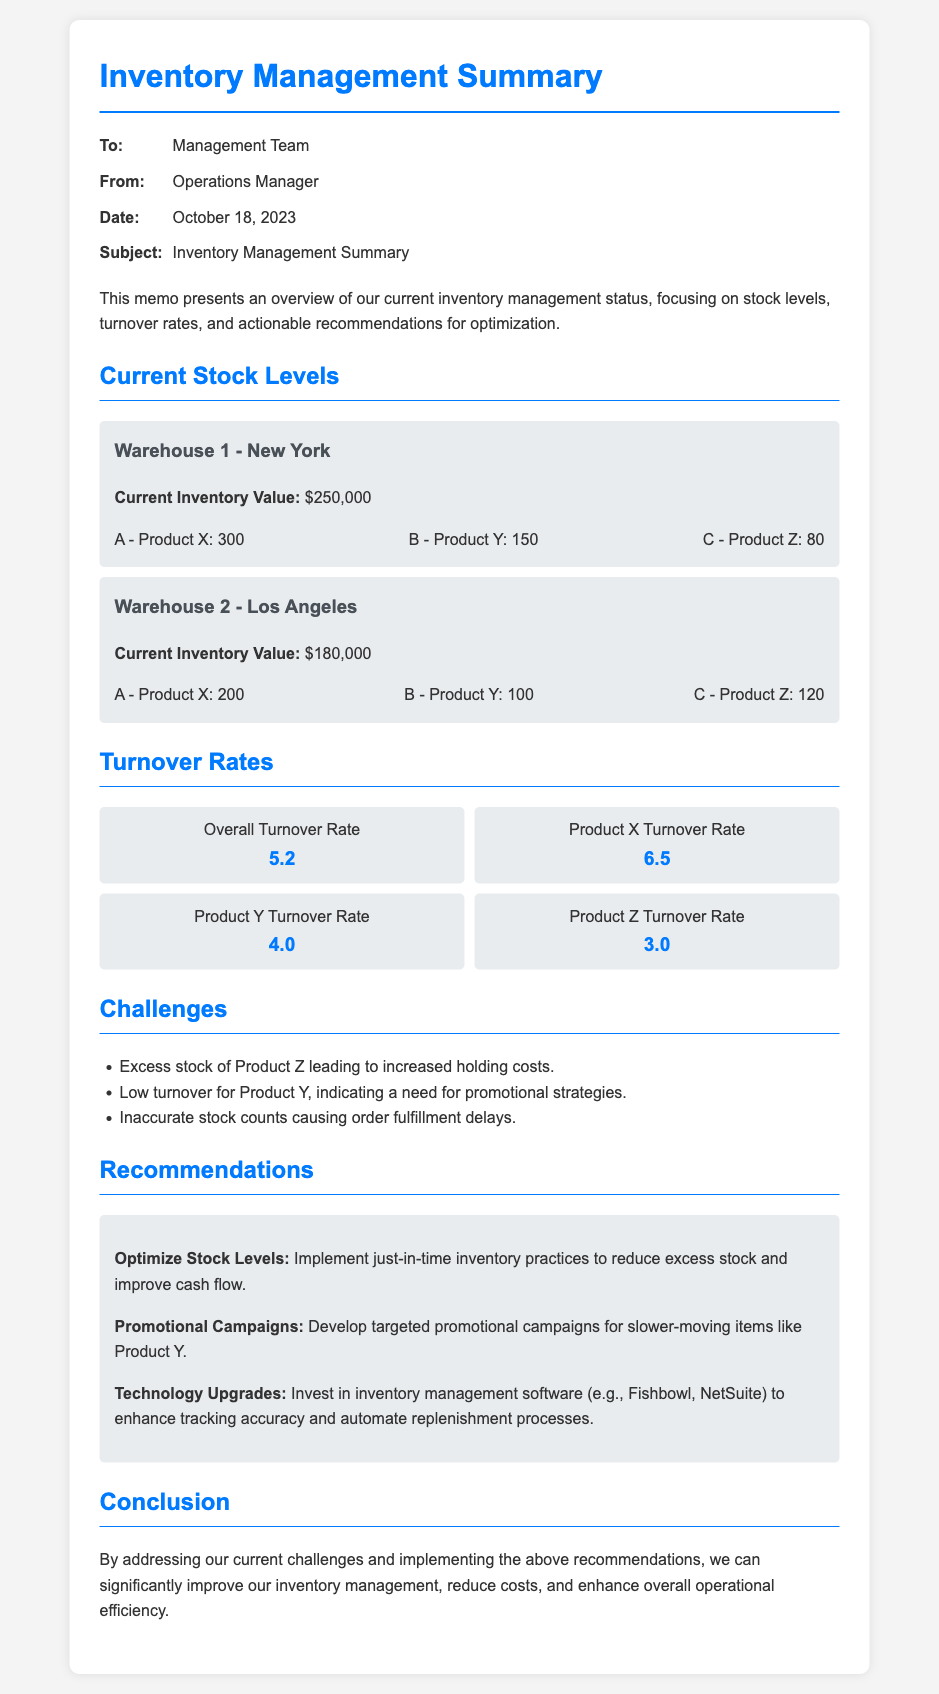What is the current inventory value for Warehouse 1? The current inventory value for Warehouse 1 is specifically stated in the document as $250,000.
Answer: $250,000 What is the turnover rate for Product Y? The turnover rate for Product Y is clearly mentioned in the turnover rates section as 4.0.
Answer: 4.0 What issue is highlighted regarding Product Z? The document points out that there is excess stock of Product Z, which leads to increased holding costs.
Answer: Excess stock What recommendation is made for Product Y? The memo suggests developing targeted promotional campaigns to address the slow turnover of Product Y.
Answer: Promotional campaigns What is the overall turnover rate? The overall turnover rate is provided in the memo as 5.2, reflecting the performance of the inventory.
Answer: 5.2 What is the date of the memo? The date of the memo is crucial information included in the metadata section, which is October 18, 2023.
Answer: October 18, 2023 What technology upgrade is recommended? The document recommends investing in inventory management software like Fishbowl or NetSuite to enhance tracking accuracy.
Answer: Inventory management software What challenge is associated with stock counts? The document mentions that inaccurate stock counts are causing order fulfillment delays.
Answer: Order fulfillment delays Which warehouse has a higher current inventory value, Warehouse 1 or Warehouse 2? The comparison of current inventory values in the memo indicates that Warehouse 1 ($250,000) has a higher value than Warehouse 2 ($180,000).
Answer: Warehouse 1 